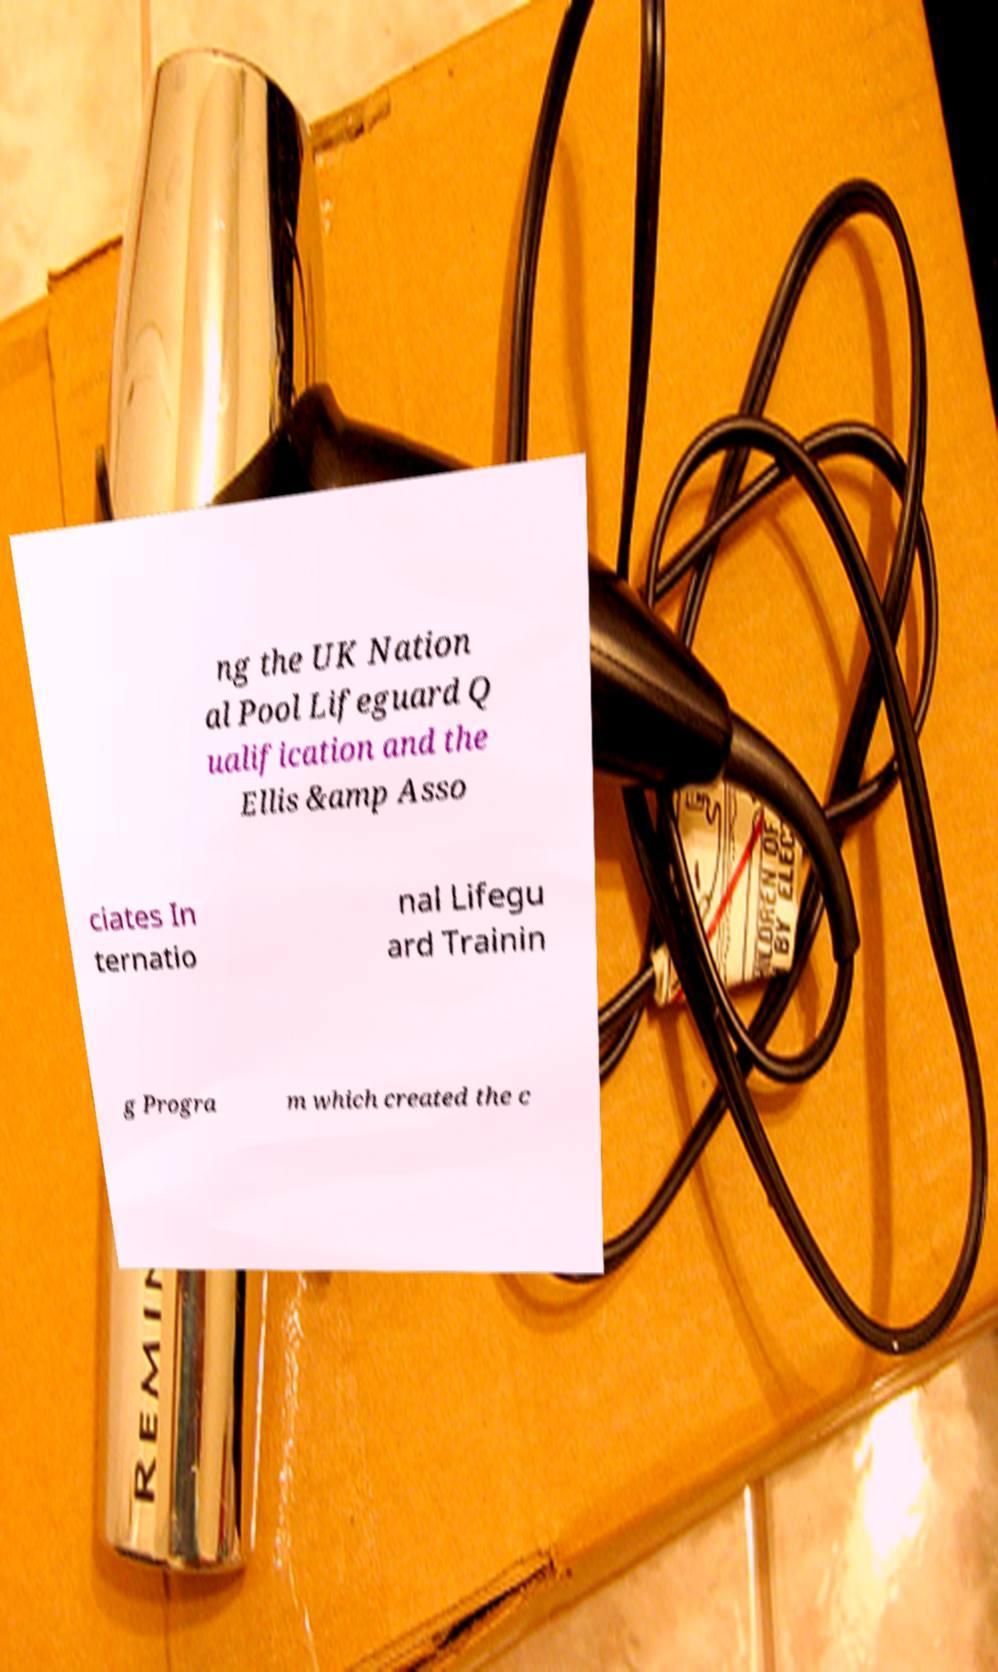Could you assist in decoding the text presented in this image and type it out clearly? ng the UK Nation al Pool Lifeguard Q ualification and the Ellis &amp Asso ciates In ternatio nal Lifegu ard Trainin g Progra m which created the c 